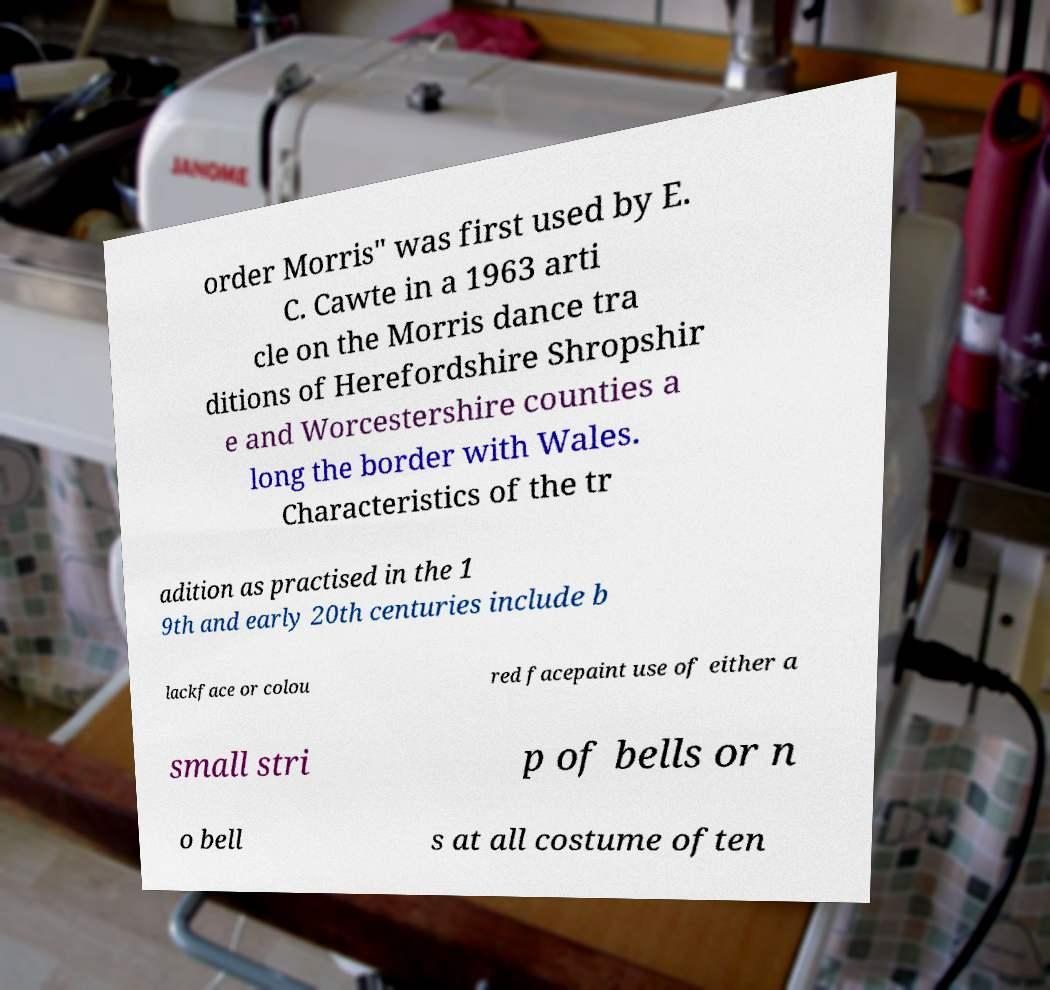Can you accurately transcribe the text from the provided image for me? order Morris" was first used by E. C. Cawte in a 1963 arti cle on the Morris dance tra ditions of Herefordshire Shropshir e and Worcestershire counties a long the border with Wales. Characteristics of the tr adition as practised in the 1 9th and early 20th centuries include b lackface or colou red facepaint use of either a small stri p of bells or n o bell s at all costume often 